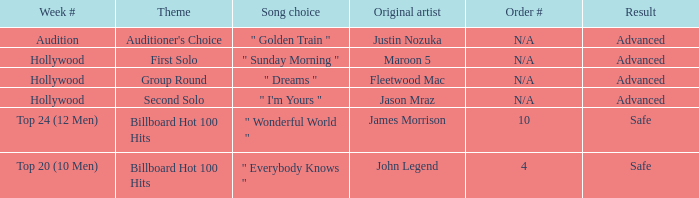What are all the week numbers where the subject matter is the auditioner's selection? Audition. 